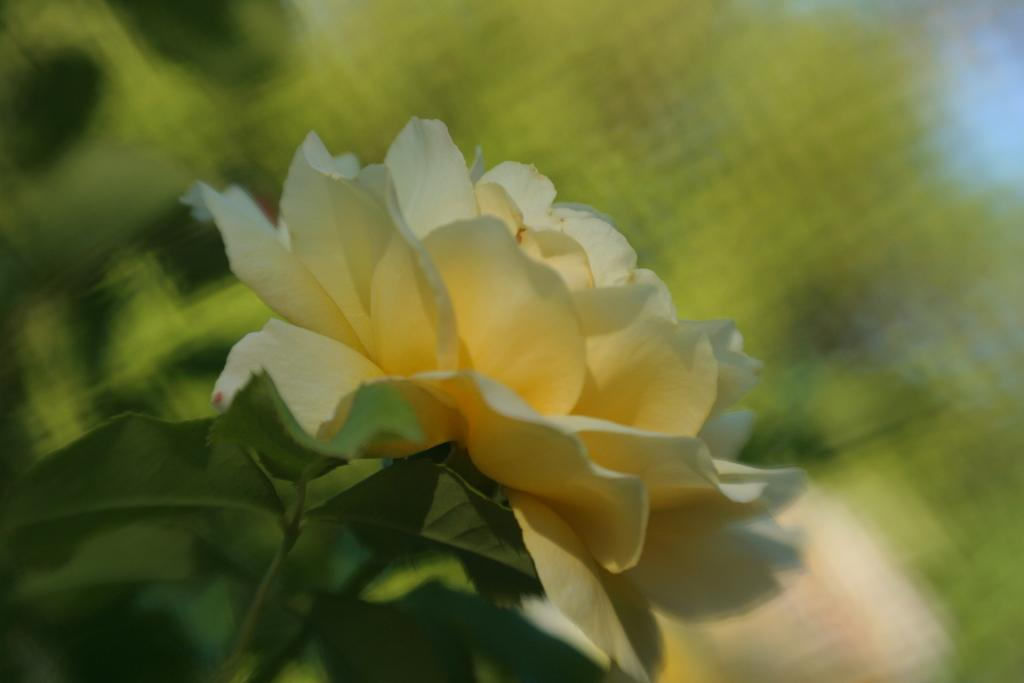What is the main subject of the image? The main subject of the image is a flower. Can you describe the flower in more detail? The flower has a stem. What else can be seen on the stem? The stem has leaves. How many boys are playing with the drain in the image? There are no boys or drains present in the image; it features a flower with a stem and leaves. 